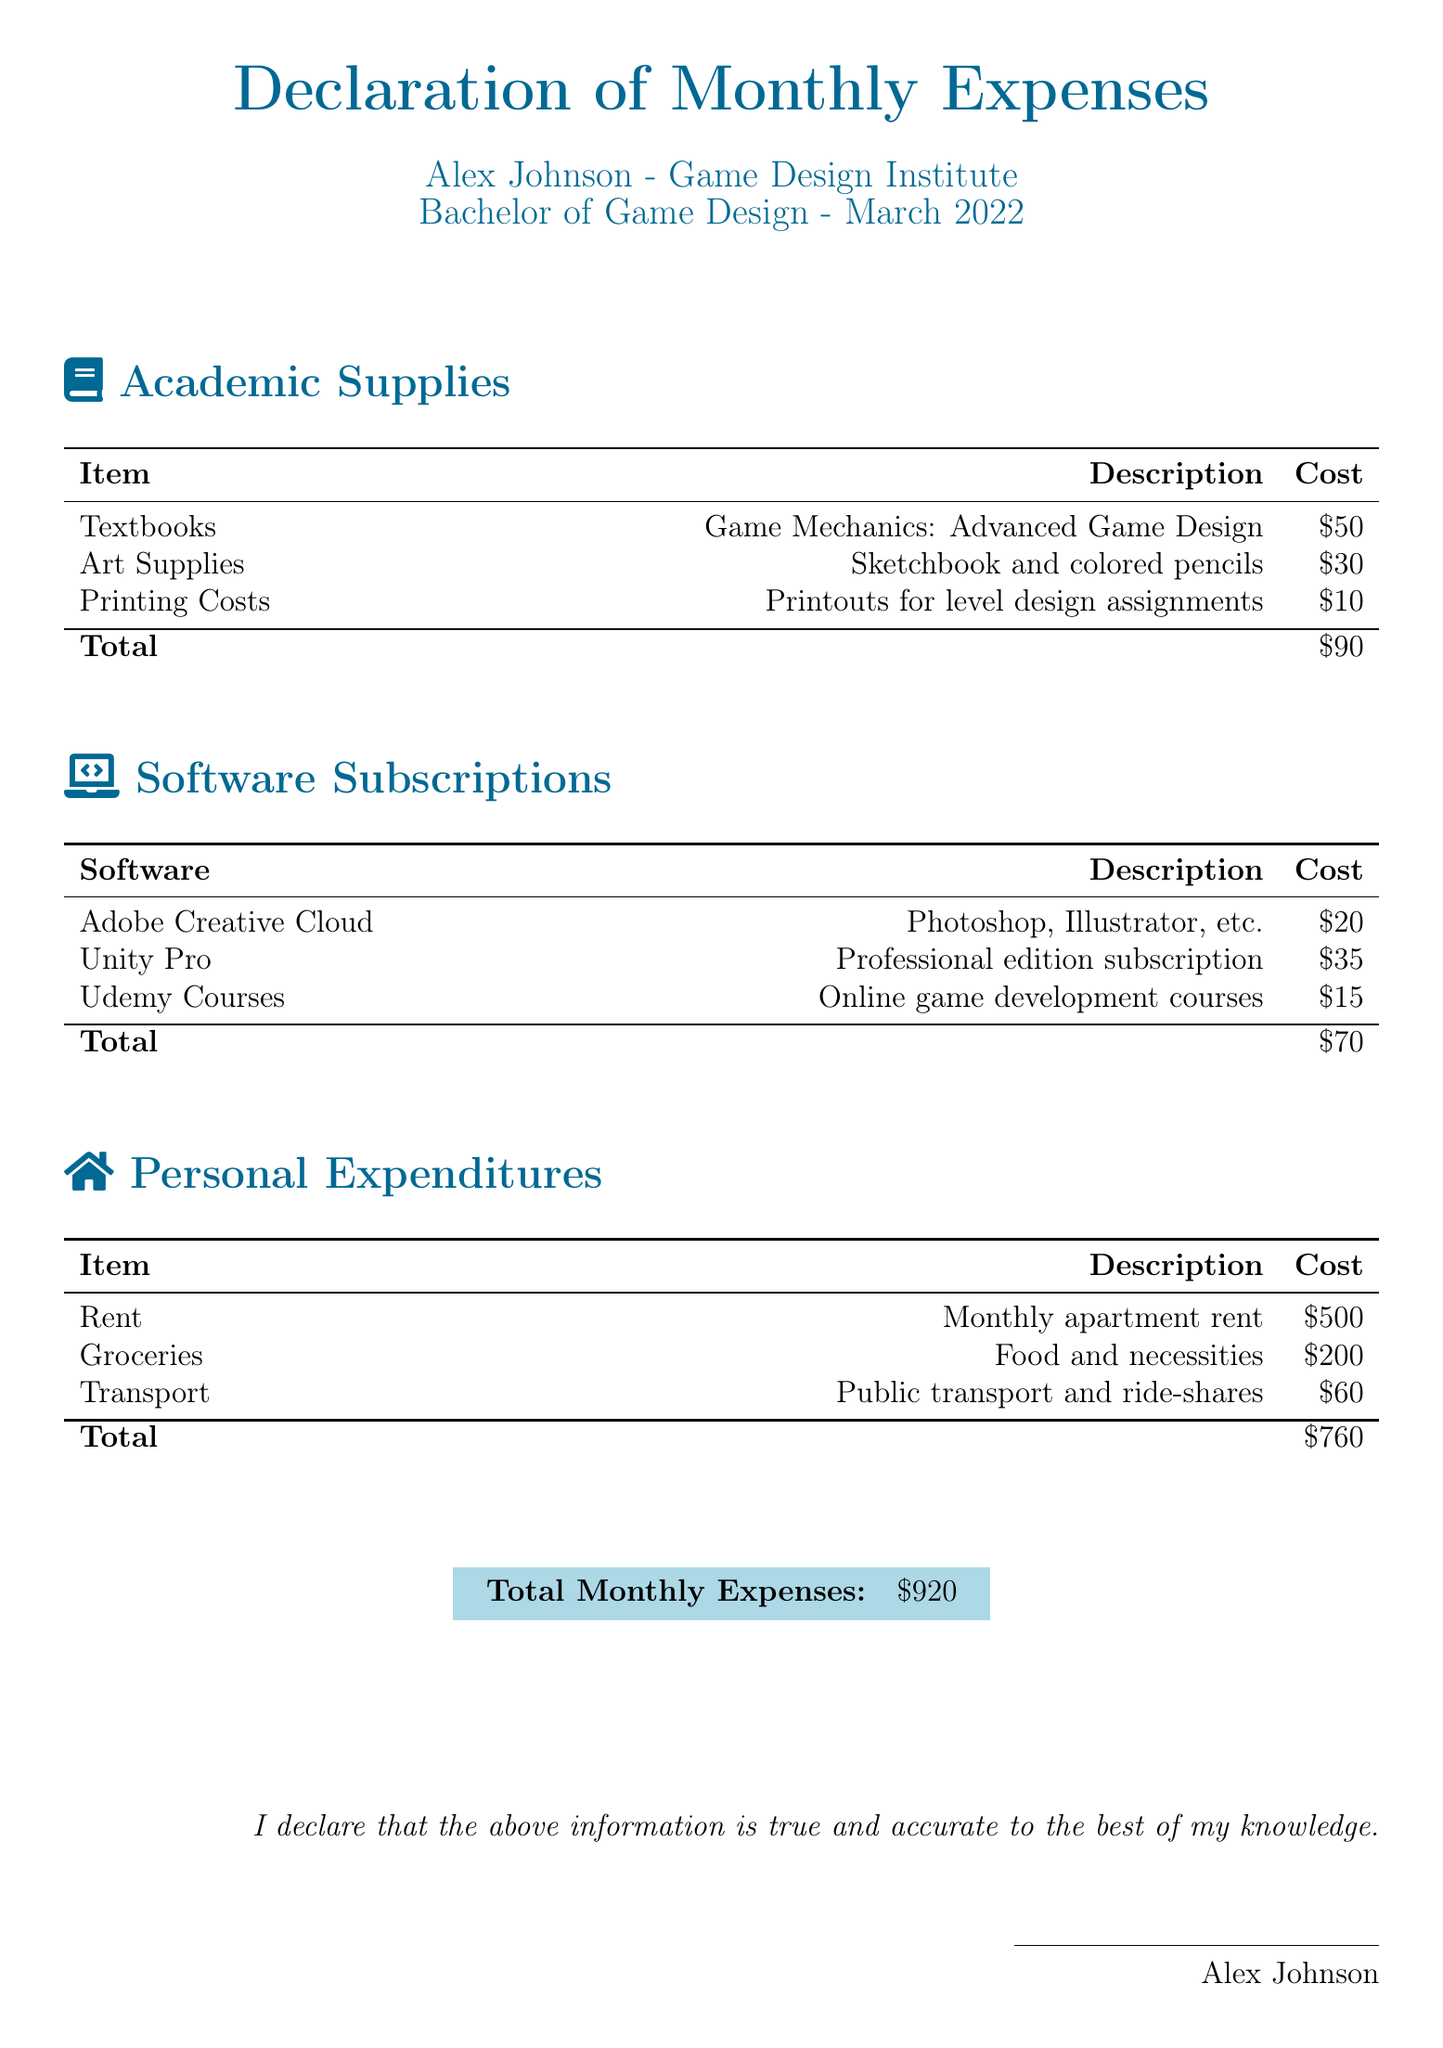What is the total cost for academic supplies? The total cost for academic supplies is found in the summary section of the academic supplies breakdown, which totals $90.
Answer: $90 What item costs $35 in software subscriptions? The software subscription cost of $35 corresponds to the professional edition of Unity Pro, as indicated in the document.
Answer: Unity Pro How much is allocated for rent in personal expenditures? The rent is listed under personal expenditures, specifically as the monthly apartment rent, which amounts to $500.
Answer: $500 What is the total of personal expenditures? The total of personal expenditures is provided in the summary section of the personal expenditures breakdown and adds up to $760.
Answer: $760 How many items are listed under academic supplies? There are three items detailed in the academic supplies section, as per the list presented in the document.
Answer: 3 Which course provider is mentioned in the software subscriptions? The course provider mentioned in the software subscriptions is Udemy, which offers online game development courses.
Answer: Udemy What is the declaration date for the expenses? The declaration is specified for the month of March 2022, denoting when the expenses are recorded.
Answer: March 2022 What is the total amount for all the monthly expenses? The total monthly expenses section compiles all expenses, concluding with a grand total of $920.
Answer: $920 